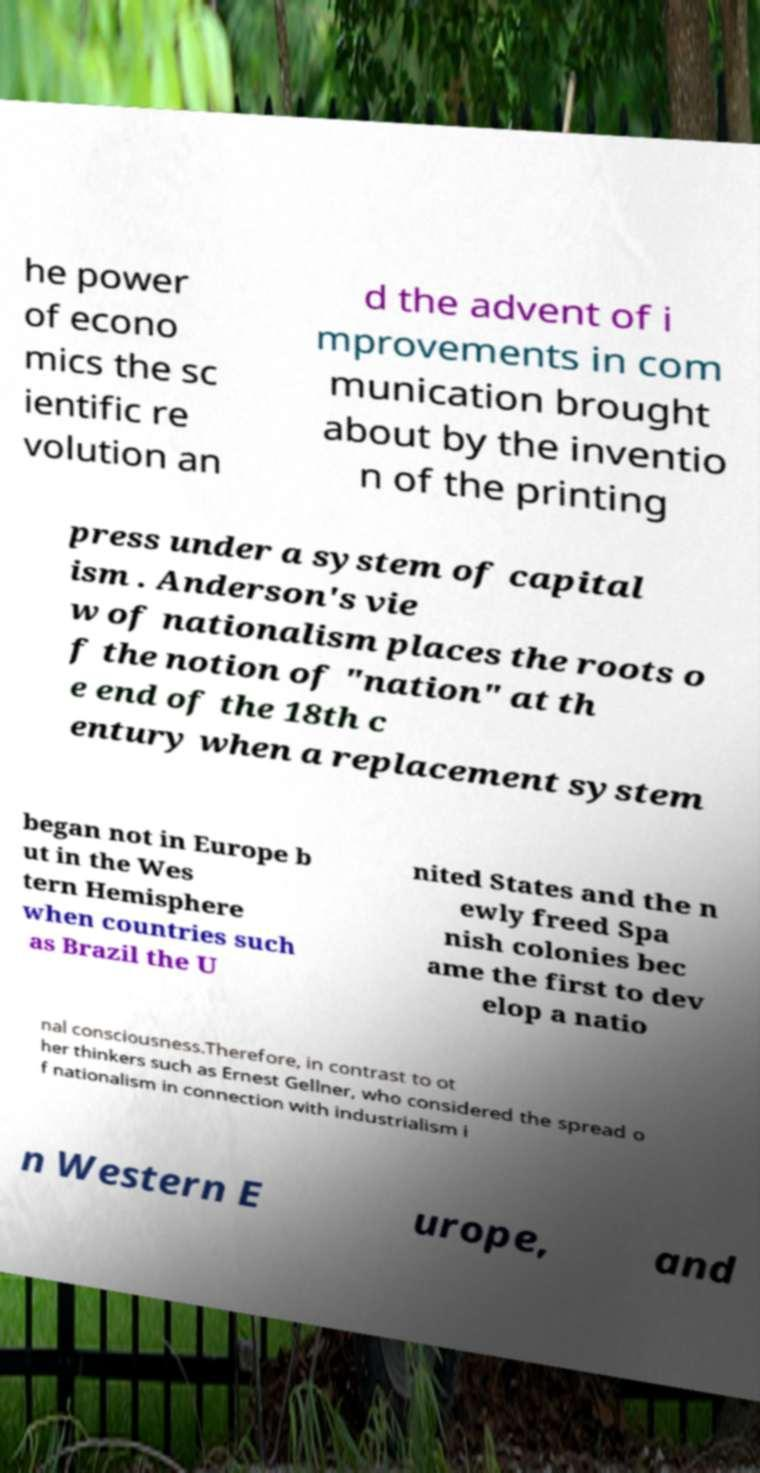There's text embedded in this image that I need extracted. Can you transcribe it verbatim? he power of econo mics the sc ientific re volution an d the advent of i mprovements in com munication brought about by the inventio n of the printing press under a system of capital ism . Anderson's vie w of nationalism places the roots o f the notion of "nation" at th e end of the 18th c entury when a replacement system began not in Europe b ut in the Wes tern Hemisphere when countries such as Brazil the U nited States and the n ewly freed Spa nish colonies bec ame the first to dev elop a natio nal consciousness.Therefore, in contrast to ot her thinkers such as Ernest Gellner, who considered the spread o f nationalism in connection with industrialism i n Western E urope, and 